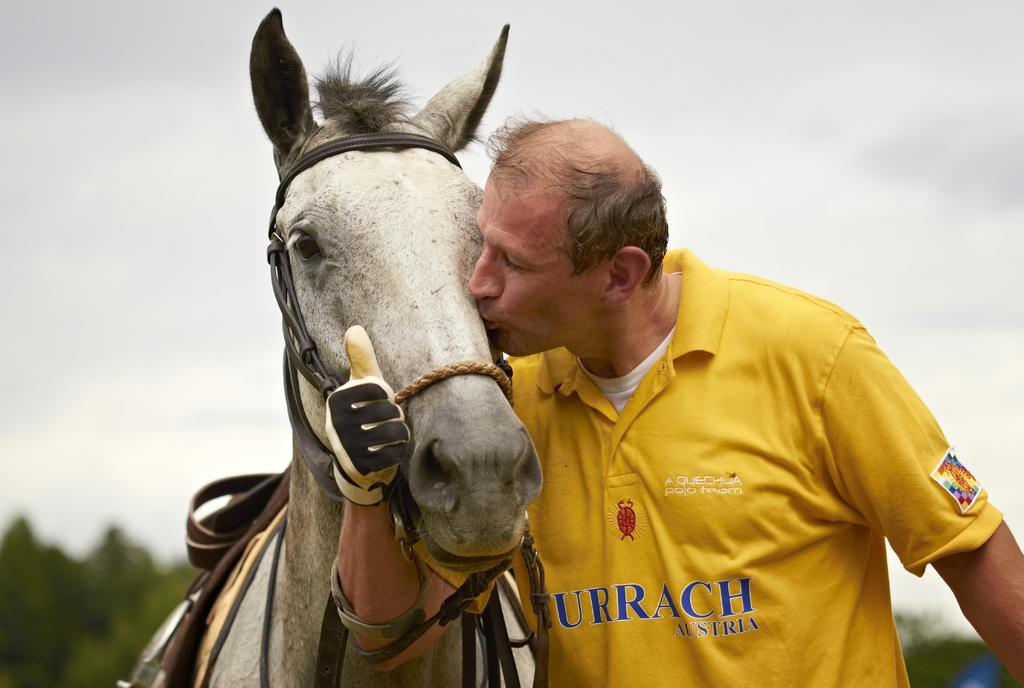What is the main subject of the image? There is a man in the image. What is the man doing in the image? The man is kissing a horse. What can be seen in the background of the image? There is a sky visible in the background of the image. What type of yarn is being used to create the circle in the image? There is no yarn or circle present in the image; it features a man kissing a horse with a sky visible in the background. 